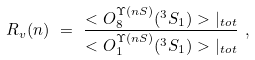<formula> <loc_0><loc_0><loc_500><loc_500>R _ { v } ( n ) \ = \ \frac { < O _ { 8 } ^ { \Upsilon ( n S ) } ( ^ { 3 } S _ { 1 } ) > { | } _ { t o t } } { < O _ { 1 } ^ { \Upsilon ( n S ) } ( ^ { 3 } S _ { 1 } ) > { | } _ { t o t } } \ ,</formula> 